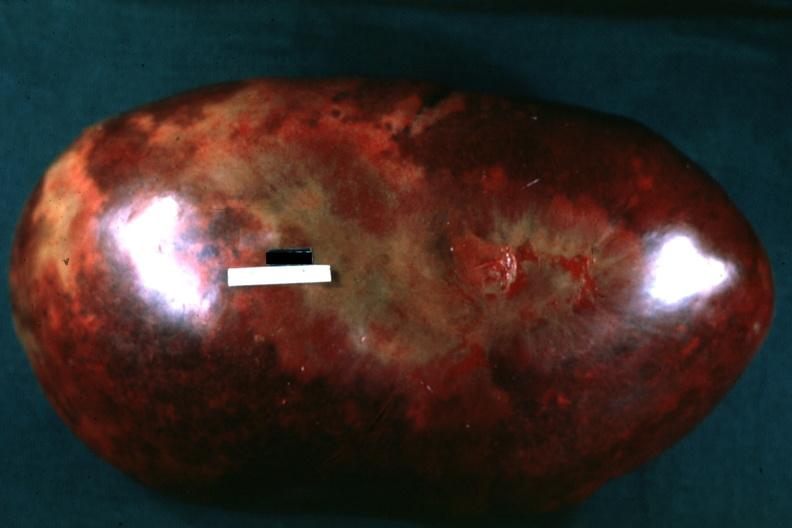what is present?
Answer the question using a single word or phrase. Spleen 